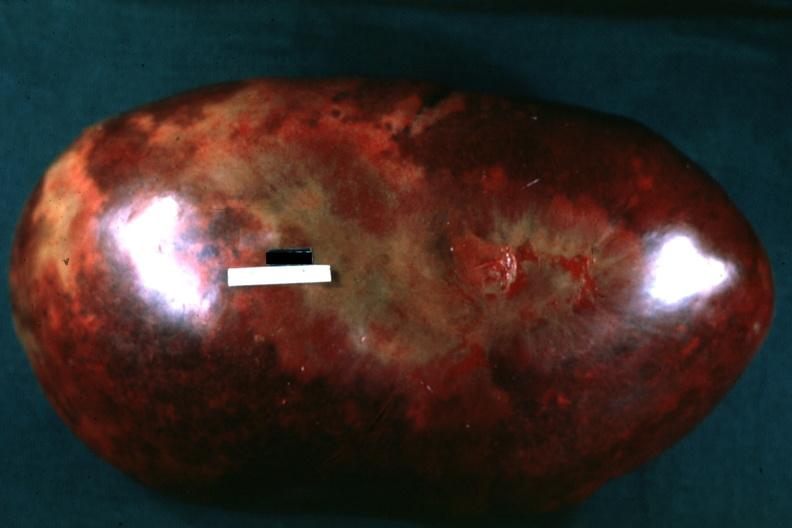what is present?
Answer the question using a single word or phrase. Spleen 